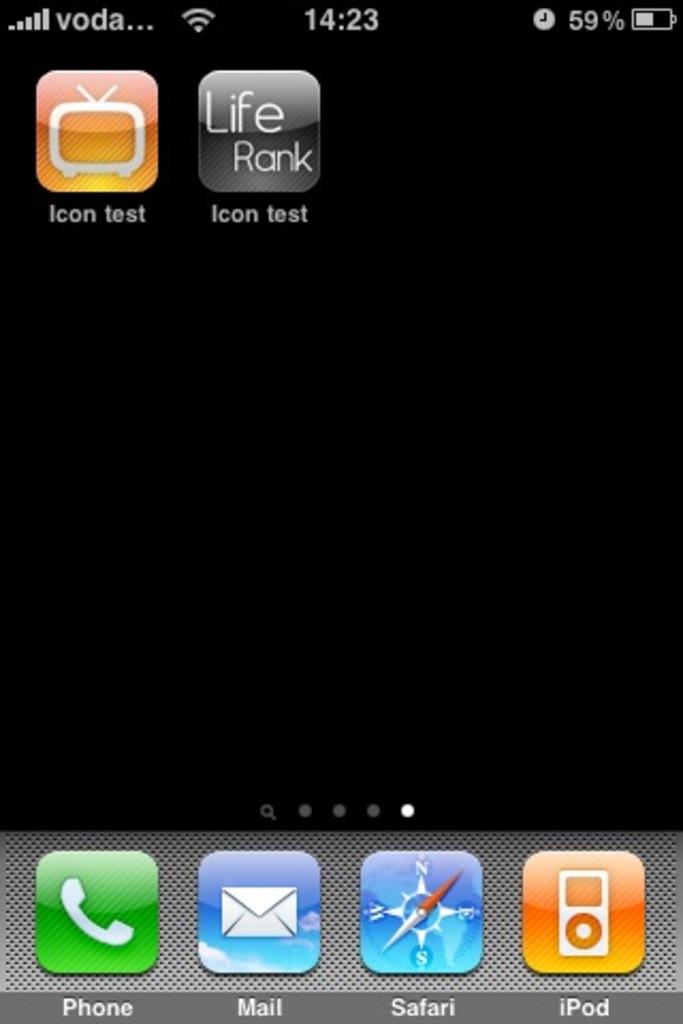The name is safari?
Offer a very short reply. Yes. 